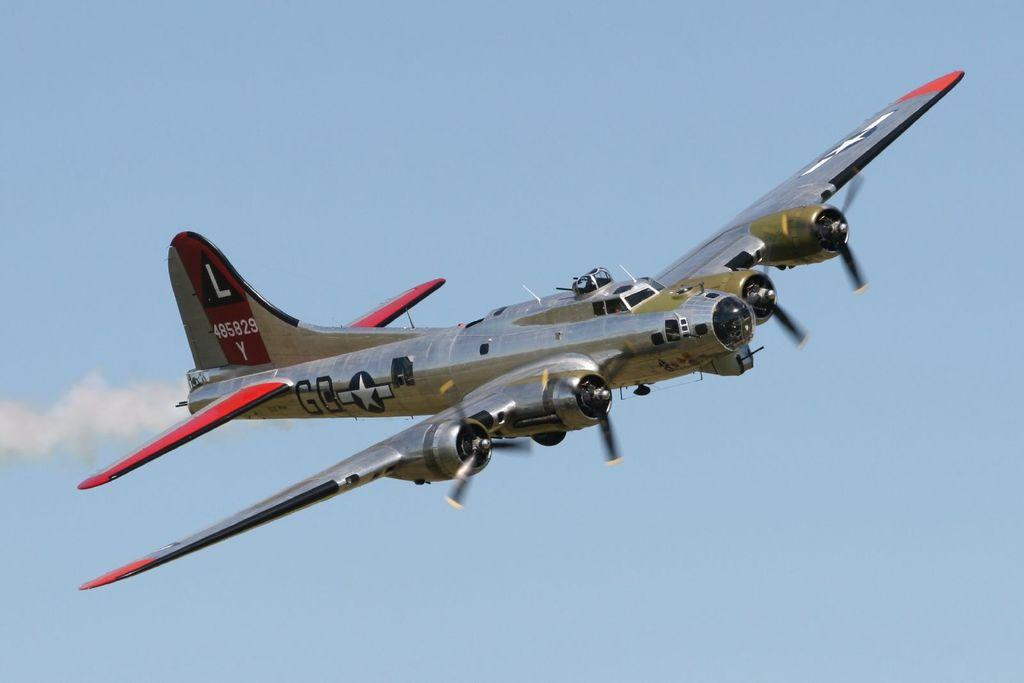<image>
Describe the image concisely. Plane flying in the air with a large letter L on it's tail. 